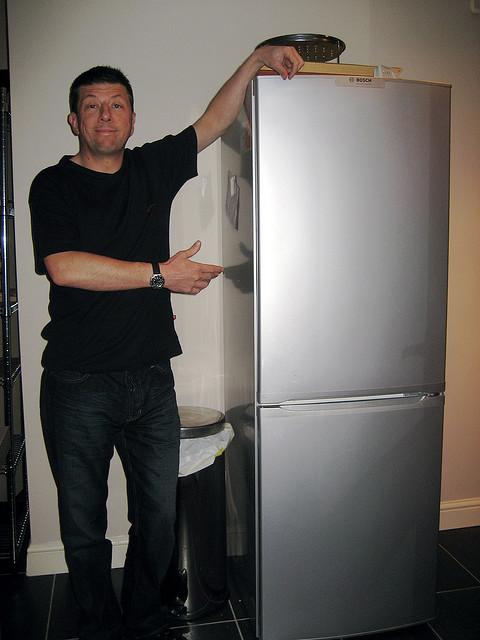What color is the man's shirt?
Quick response, please. Black. What color is the appliance?
Be succinct. Silver. What is the man showing off?
Keep it brief. Refrigerator. Is the man wearing shorts?
Write a very short answer. No. 